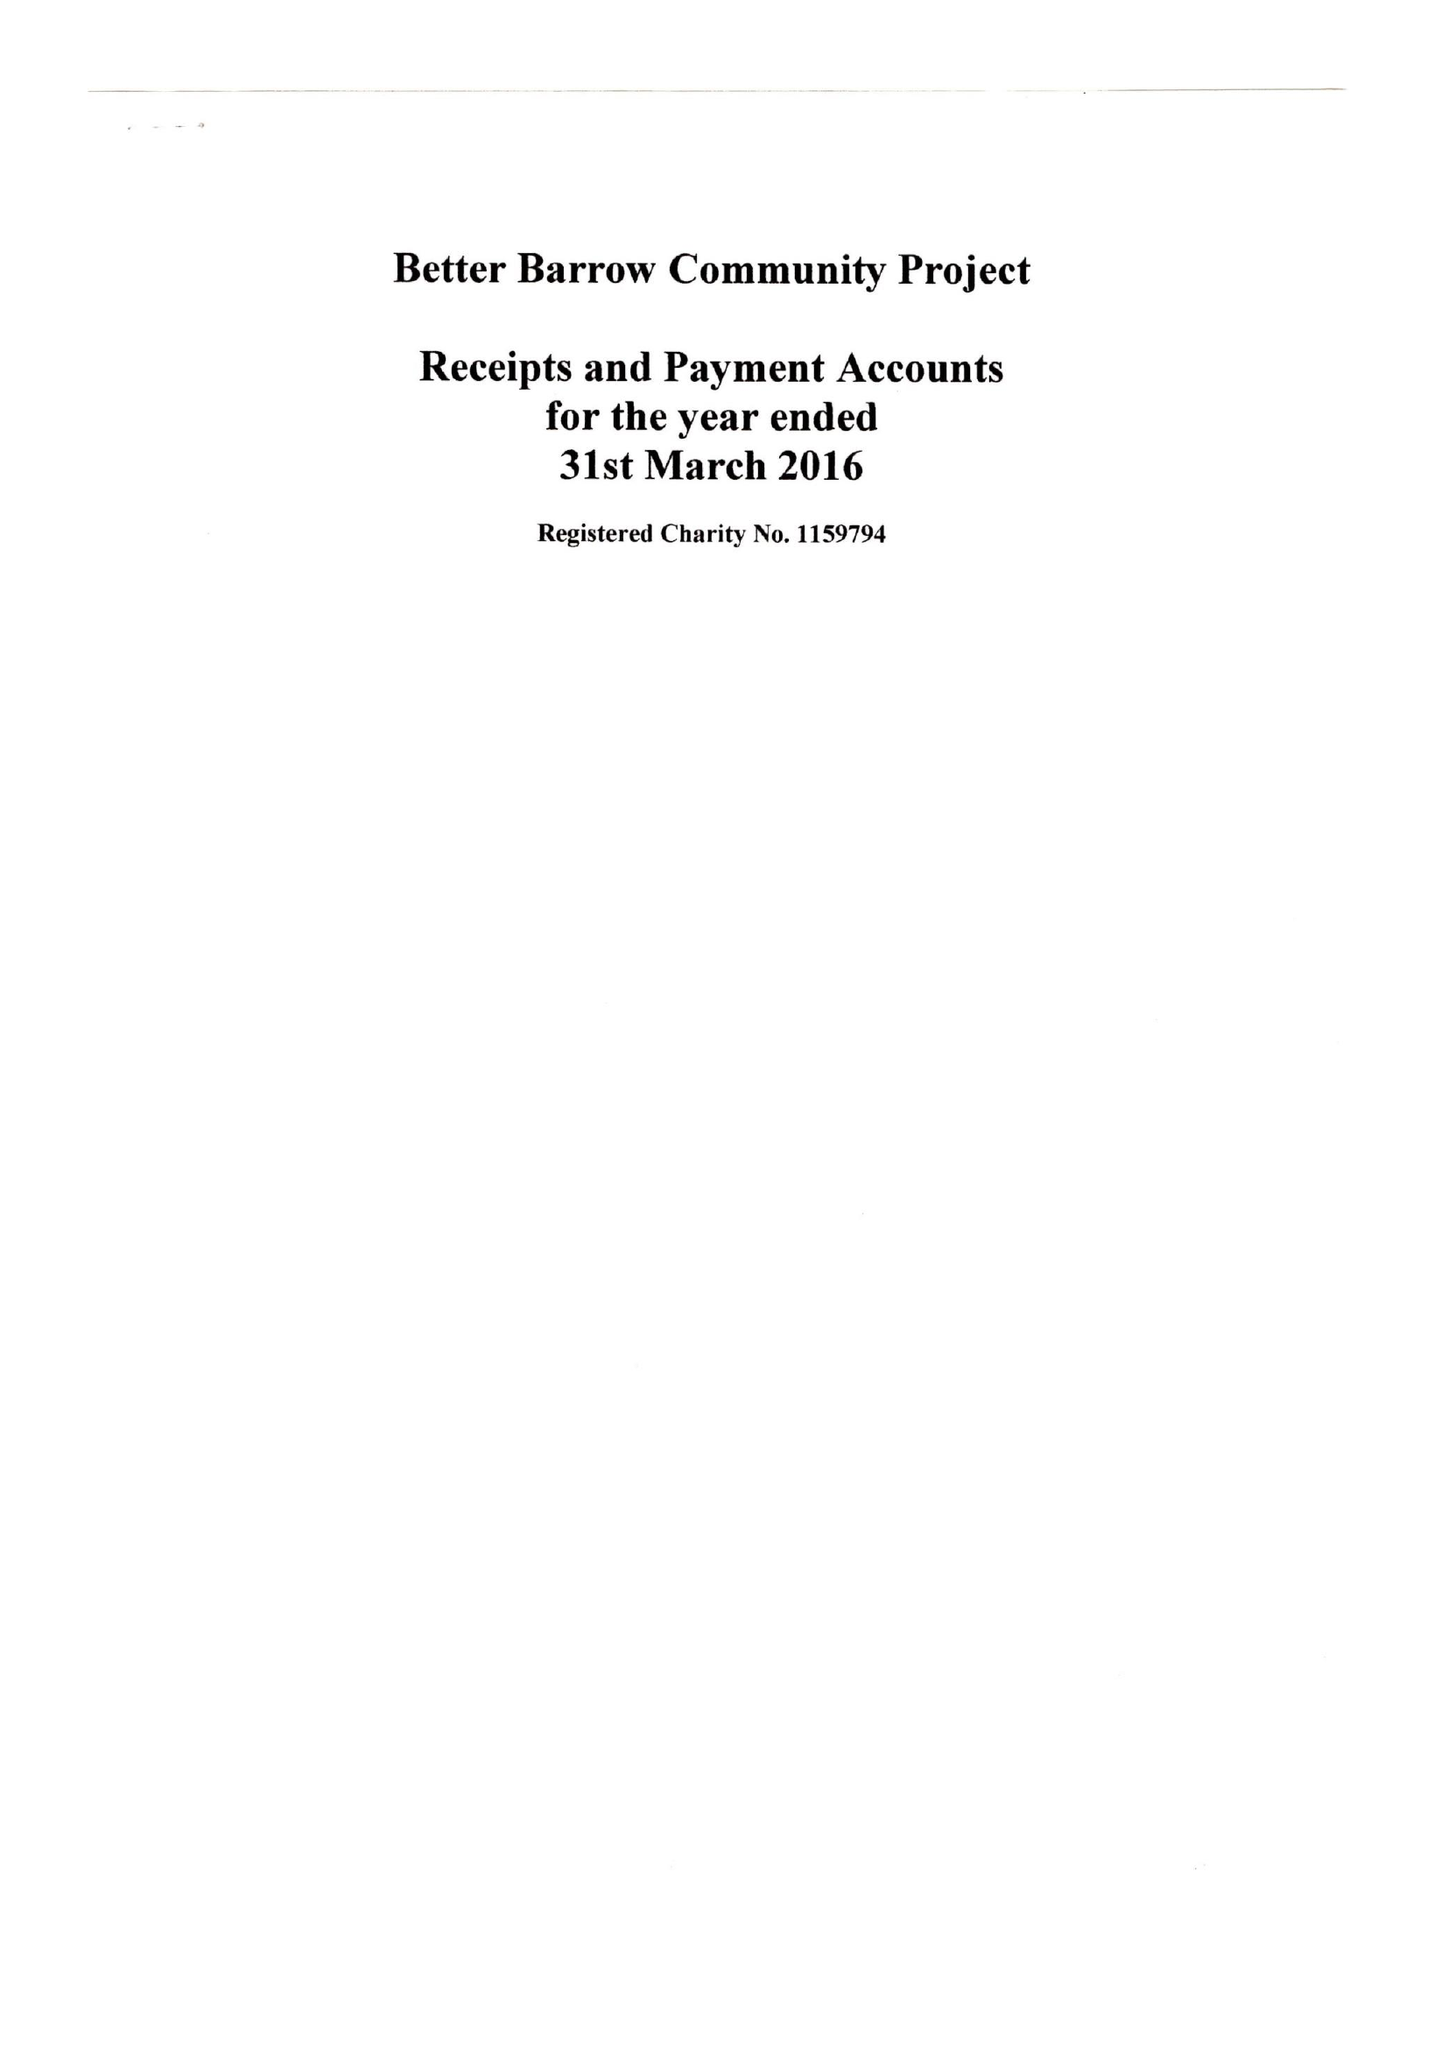What is the value for the spending_annually_in_british_pounds?
Answer the question using a single word or phrase. 1720.00 